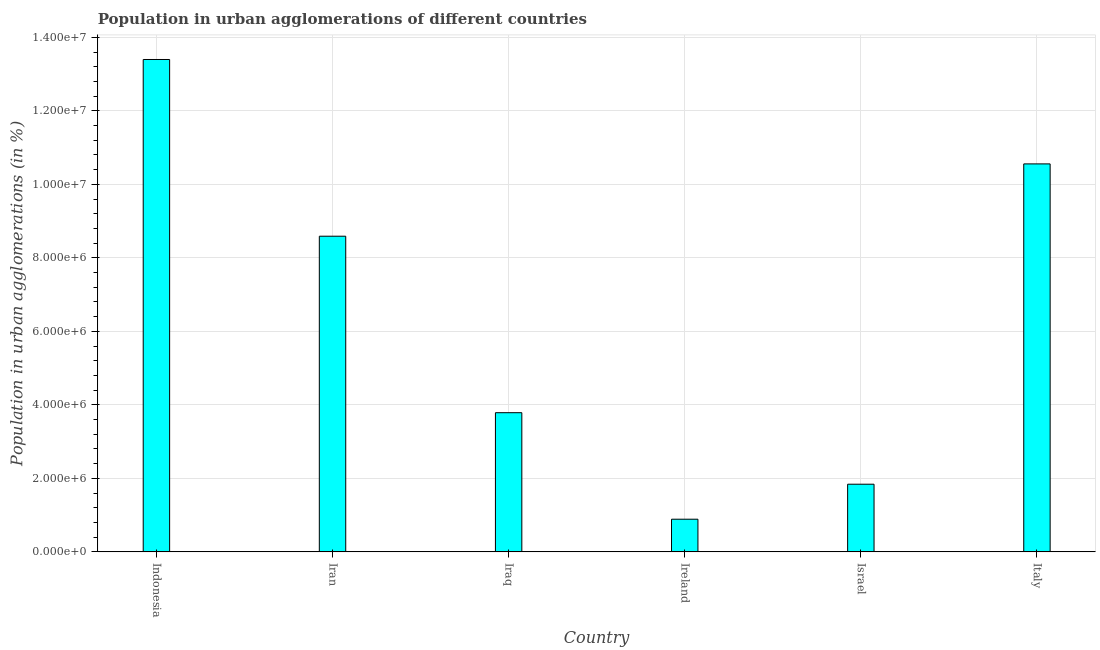Does the graph contain grids?
Offer a very short reply. Yes. What is the title of the graph?
Provide a succinct answer. Population in urban agglomerations of different countries. What is the label or title of the X-axis?
Your answer should be compact. Country. What is the label or title of the Y-axis?
Give a very brief answer. Population in urban agglomerations (in %). What is the population in urban agglomerations in Indonesia?
Ensure brevity in your answer.  1.34e+07. Across all countries, what is the maximum population in urban agglomerations?
Your answer should be compact. 1.34e+07. Across all countries, what is the minimum population in urban agglomerations?
Keep it short and to the point. 8.89e+05. In which country was the population in urban agglomerations maximum?
Your response must be concise. Indonesia. In which country was the population in urban agglomerations minimum?
Your answer should be very brief. Ireland. What is the sum of the population in urban agglomerations?
Your answer should be compact. 3.91e+07. What is the difference between the population in urban agglomerations in Iraq and Israel?
Provide a short and direct response. 1.95e+06. What is the average population in urban agglomerations per country?
Make the answer very short. 6.51e+06. What is the median population in urban agglomerations?
Give a very brief answer. 6.19e+06. What is the ratio of the population in urban agglomerations in Indonesia to that in Iran?
Ensure brevity in your answer.  1.56. Is the population in urban agglomerations in Indonesia less than that in Iran?
Give a very brief answer. No. Is the difference between the population in urban agglomerations in Ireland and Israel greater than the difference between any two countries?
Your response must be concise. No. What is the difference between the highest and the second highest population in urban agglomerations?
Your response must be concise. 2.84e+06. Is the sum of the population in urban agglomerations in Ireland and Israel greater than the maximum population in urban agglomerations across all countries?
Provide a short and direct response. No. What is the difference between the highest and the lowest population in urban agglomerations?
Offer a terse response. 1.25e+07. In how many countries, is the population in urban agglomerations greater than the average population in urban agglomerations taken over all countries?
Give a very brief answer. 3. How many countries are there in the graph?
Provide a succinct answer. 6. What is the difference between two consecutive major ticks on the Y-axis?
Your answer should be very brief. 2.00e+06. Are the values on the major ticks of Y-axis written in scientific E-notation?
Your answer should be compact. Yes. What is the Population in urban agglomerations (in %) in Indonesia?
Offer a very short reply. 1.34e+07. What is the Population in urban agglomerations (in %) of Iran?
Make the answer very short. 8.59e+06. What is the Population in urban agglomerations (in %) of Iraq?
Provide a succinct answer. 3.79e+06. What is the Population in urban agglomerations (in %) of Ireland?
Offer a terse response. 8.89e+05. What is the Population in urban agglomerations (in %) of Israel?
Offer a terse response. 1.84e+06. What is the Population in urban agglomerations (in %) of Italy?
Your answer should be very brief. 1.06e+07. What is the difference between the Population in urban agglomerations (in %) in Indonesia and Iran?
Provide a short and direct response. 4.81e+06. What is the difference between the Population in urban agglomerations (in %) in Indonesia and Iraq?
Offer a terse response. 9.61e+06. What is the difference between the Population in urban agglomerations (in %) in Indonesia and Ireland?
Ensure brevity in your answer.  1.25e+07. What is the difference between the Population in urban agglomerations (in %) in Indonesia and Israel?
Offer a terse response. 1.16e+07. What is the difference between the Population in urban agglomerations (in %) in Indonesia and Italy?
Provide a short and direct response. 2.84e+06. What is the difference between the Population in urban agglomerations (in %) in Iran and Iraq?
Ensure brevity in your answer.  4.80e+06. What is the difference between the Population in urban agglomerations (in %) in Iran and Ireland?
Make the answer very short. 7.70e+06. What is the difference between the Population in urban agglomerations (in %) in Iran and Israel?
Ensure brevity in your answer.  6.75e+06. What is the difference between the Population in urban agglomerations (in %) in Iran and Italy?
Your answer should be compact. -1.97e+06. What is the difference between the Population in urban agglomerations (in %) in Iraq and Ireland?
Ensure brevity in your answer.  2.90e+06. What is the difference between the Population in urban agglomerations (in %) in Iraq and Israel?
Offer a terse response. 1.95e+06. What is the difference between the Population in urban agglomerations (in %) in Iraq and Italy?
Your response must be concise. -6.77e+06. What is the difference between the Population in urban agglomerations (in %) in Ireland and Israel?
Ensure brevity in your answer.  -9.52e+05. What is the difference between the Population in urban agglomerations (in %) in Ireland and Italy?
Make the answer very short. -9.67e+06. What is the difference between the Population in urban agglomerations (in %) in Israel and Italy?
Provide a succinct answer. -8.72e+06. What is the ratio of the Population in urban agglomerations (in %) in Indonesia to that in Iran?
Your answer should be very brief. 1.56. What is the ratio of the Population in urban agglomerations (in %) in Indonesia to that in Iraq?
Offer a very short reply. 3.54. What is the ratio of the Population in urban agglomerations (in %) in Indonesia to that in Ireland?
Offer a terse response. 15.07. What is the ratio of the Population in urban agglomerations (in %) in Indonesia to that in Israel?
Offer a terse response. 7.28. What is the ratio of the Population in urban agglomerations (in %) in Indonesia to that in Italy?
Provide a succinct answer. 1.27. What is the ratio of the Population in urban agglomerations (in %) in Iran to that in Iraq?
Offer a very short reply. 2.27. What is the ratio of the Population in urban agglomerations (in %) in Iran to that in Ireland?
Offer a terse response. 9.66. What is the ratio of the Population in urban agglomerations (in %) in Iran to that in Israel?
Offer a very short reply. 4.67. What is the ratio of the Population in urban agglomerations (in %) in Iran to that in Italy?
Provide a short and direct response. 0.81. What is the ratio of the Population in urban agglomerations (in %) in Iraq to that in Ireland?
Your response must be concise. 4.26. What is the ratio of the Population in urban agglomerations (in %) in Iraq to that in Israel?
Your answer should be very brief. 2.06. What is the ratio of the Population in urban agglomerations (in %) in Iraq to that in Italy?
Provide a succinct answer. 0.36. What is the ratio of the Population in urban agglomerations (in %) in Ireland to that in Israel?
Provide a succinct answer. 0.48. What is the ratio of the Population in urban agglomerations (in %) in Ireland to that in Italy?
Give a very brief answer. 0.08. What is the ratio of the Population in urban agglomerations (in %) in Israel to that in Italy?
Give a very brief answer. 0.17. 